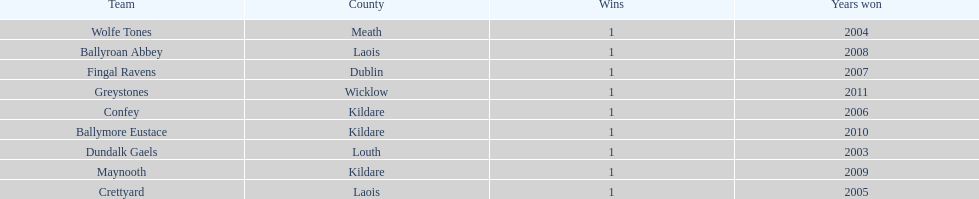What is the last team on the chart Dundalk Gaels. 